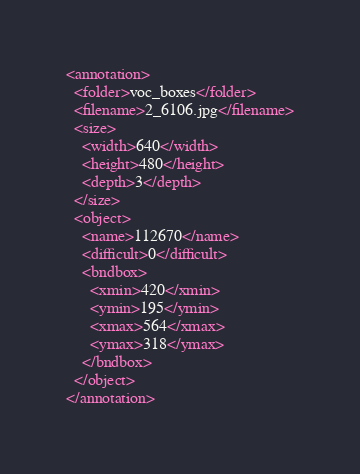<code> <loc_0><loc_0><loc_500><loc_500><_XML_><annotation>
  <folder>voc_boxes</folder>
  <filename>2_6106.jpg</filename>
  <size>
    <width>640</width>
    <height>480</height>
    <depth>3</depth>
  </size>
  <object>
    <name>112670</name>
    <difficult>0</difficult>
    <bndbox>
      <xmin>420</xmin>
      <ymin>195</ymin>
      <xmax>564</xmax>
      <ymax>318</ymax>
    </bndbox>
  </object>
</annotation></code> 